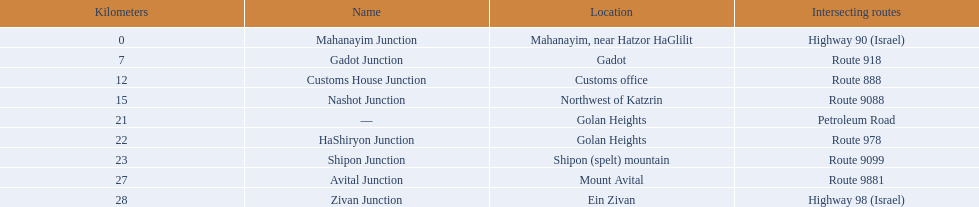Which intersections can be found on numbered routes, excluding highways or other types? Gadot Junction, Customs House Junction, Nashot Junction, HaShiryon Junction, Shipon Junction, Avital Junction. Among these intersections, which ones are situated on four-digit routes (e.g., route 9999)? Nashot Junction, Shipon Junction, Avital Junction. Lastly, from the remaining routes, which one is positioned on shipon mountain? Shipon Junction. 